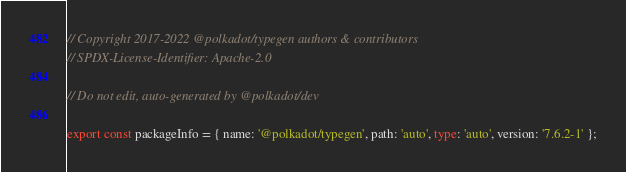Convert code to text. <code><loc_0><loc_0><loc_500><loc_500><_TypeScript_>// Copyright 2017-2022 @polkadot/typegen authors & contributors
// SPDX-License-Identifier: Apache-2.0

// Do not edit, auto-generated by @polkadot/dev

export const packageInfo = { name: '@polkadot/typegen', path: 'auto', type: 'auto', version: '7.6.2-1' };
</code> 